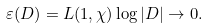Convert formula to latex. <formula><loc_0><loc_0><loc_500><loc_500>\varepsilon ( D ) = L ( 1 , \chi ) \log { | D | } \to 0 .</formula> 